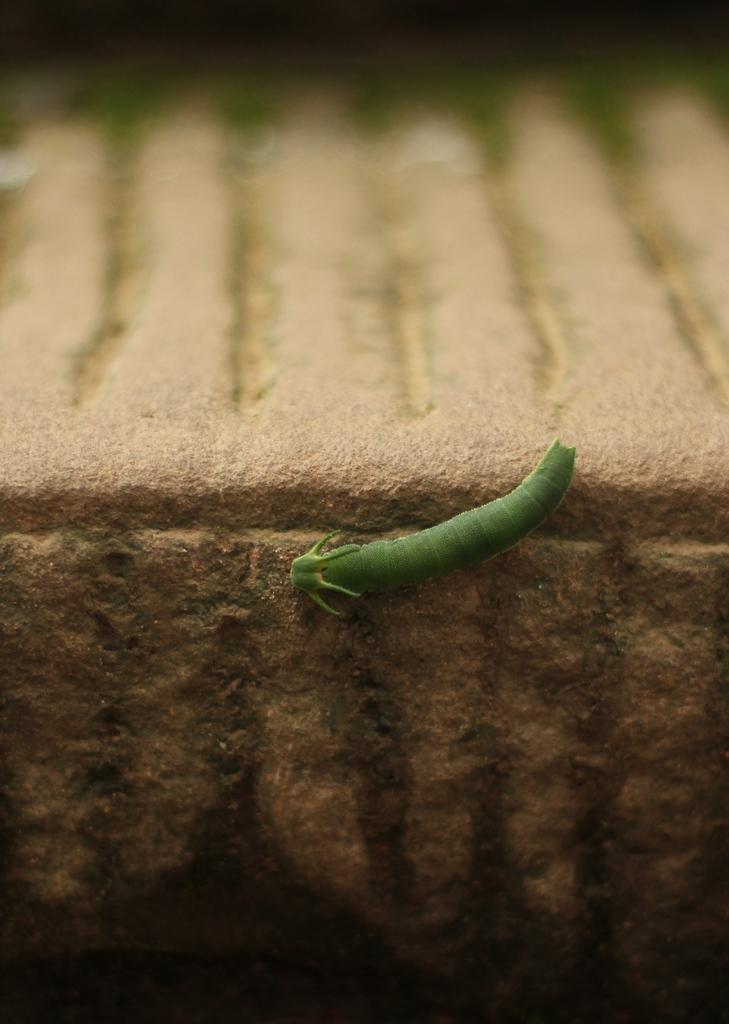Please provide a concise description of this image. In this image there is a green colour worm on the wall. 